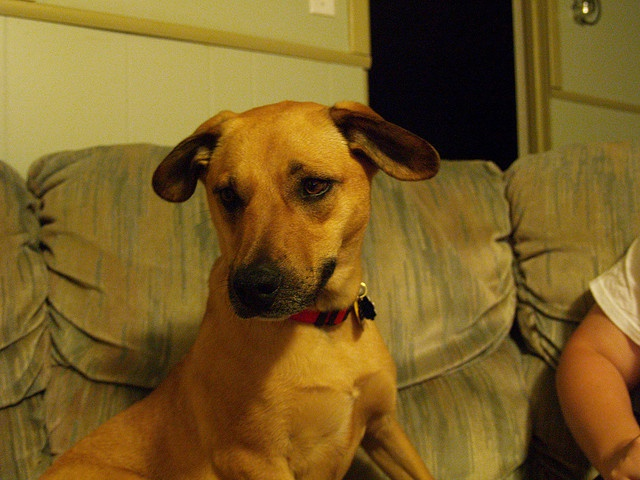Describe the objects in this image and their specific colors. I can see couch in orange, olive, black, and gray tones, dog in orange, olive, maroon, and black tones, and people in orange, red, maroon, and tan tones in this image. 